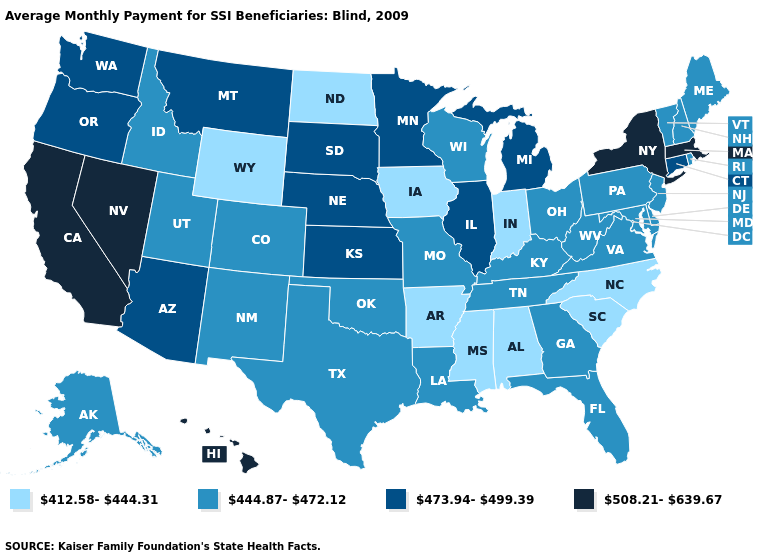Does Indiana have the lowest value in the MidWest?
Answer briefly. Yes. What is the value of Utah?
Be succinct. 444.87-472.12. Does Missouri have a higher value than Idaho?
Short answer required. No. How many symbols are there in the legend?
Short answer required. 4. Name the states that have a value in the range 473.94-499.39?
Answer briefly. Arizona, Connecticut, Illinois, Kansas, Michigan, Minnesota, Montana, Nebraska, Oregon, South Dakota, Washington. What is the highest value in the West ?
Give a very brief answer. 508.21-639.67. What is the value of Kansas?
Quick response, please. 473.94-499.39. Name the states that have a value in the range 508.21-639.67?
Be succinct. California, Hawaii, Massachusetts, Nevada, New York. What is the value of North Carolina?
Quick response, please. 412.58-444.31. What is the value of Maryland?
Be succinct. 444.87-472.12. What is the value of Wyoming?
Concise answer only. 412.58-444.31. What is the lowest value in states that border New York?
Keep it brief. 444.87-472.12. Name the states that have a value in the range 508.21-639.67?
Short answer required. California, Hawaii, Massachusetts, Nevada, New York. Does Rhode Island have a lower value than North Carolina?
Give a very brief answer. No. Name the states that have a value in the range 444.87-472.12?
Answer briefly. Alaska, Colorado, Delaware, Florida, Georgia, Idaho, Kentucky, Louisiana, Maine, Maryland, Missouri, New Hampshire, New Jersey, New Mexico, Ohio, Oklahoma, Pennsylvania, Rhode Island, Tennessee, Texas, Utah, Vermont, Virginia, West Virginia, Wisconsin. 